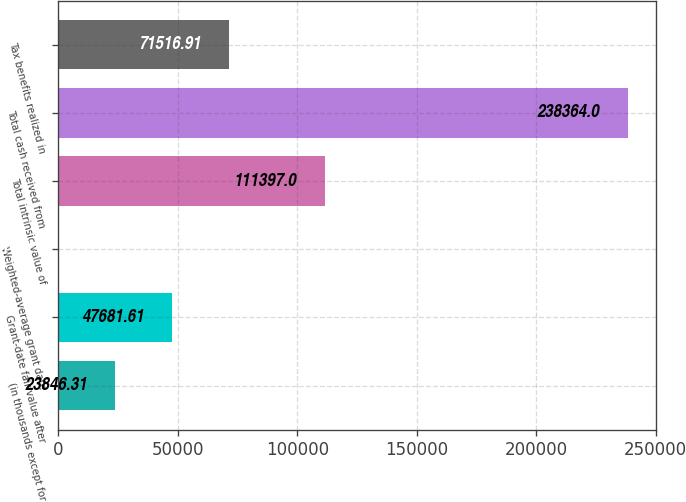<chart> <loc_0><loc_0><loc_500><loc_500><bar_chart><fcel>(in thousands except for<fcel>Grant-date fair value after<fcel>Weighted-average grant date<fcel>Total intrinsic value of<fcel>Total cash received from<fcel>Tax benefits realized in<nl><fcel>23846.3<fcel>47681.6<fcel>11.01<fcel>111397<fcel>238364<fcel>71516.9<nl></chart> 